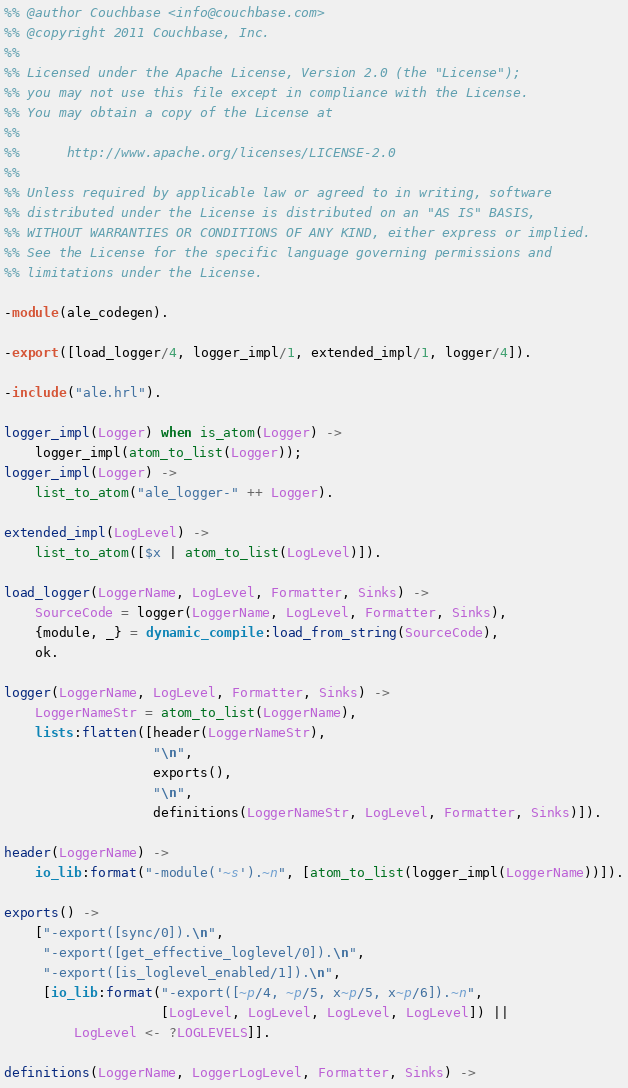<code> <loc_0><loc_0><loc_500><loc_500><_Erlang_>%% @author Couchbase <info@couchbase.com>
%% @copyright 2011 Couchbase, Inc.
%%
%% Licensed under the Apache License, Version 2.0 (the "License");
%% you may not use this file except in compliance with the License.
%% You may obtain a copy of the License at
%%
%%      http://www.apache.org/licenses/LICENSE-2.0
%%
%% Unless required by applicable law or agreed to in writing, software
%% distributed under the License is distributed on an "AS IS" BASIS,
%% WITHOUT WARRANTIES OR CONDITIONS OF ANY KIND, either express or implied.
%% See the License for the specific language governing permissions and
%% limitations under the License.

-module(ale_codegen).

-export([load_logger/4, logger_impl/1, extended_impl/1, logger/4]).

-include("ale.hrl").

logger_impl(Logger) when is_atom(Logger) ->
    logger_impl(atom_to_list(Logger));
logger_impl(Logger) ->
    list_to_atom("ale_logger-" ++ Logger).

extended_impl(LogLevel) ->
    list_to_atom([$x | atom_to_list(LogLevel)]).

load_logger(LoggerName, LogLevel, Formatter, Sinks) ->
    SourceCode = logger(LoggerName, LogLevel, Formatter, Sinks),
    {module, _} = dynamic_compile:load_from_string(SourceCode),
    ok.

logger(LoggerName, LogLevel, Formatter, Sinks) ->
    LoggerNameStr = atom_to_list(LoggerName),
    lists:flatten([header(LoggerNameStr),
                   "\n",
                   exports(),
                   "\n",
                   definitions(LoggerNameStr, LogLevel, Formatter, Sinks)]).

header(LoggerName) ->
    io_lib:format("-module('~s').~n", [atom_to_list(logger_impl(LoggerName))]).

exports() ->
    ["-export([sync/0]).\n",
     "-export([get_effective_loglevel/0]).\n",
     "-export([is_loglevel_enabled/1]).\n",
     [io_lib:format("-export([~p/4, ~p/5, x~p/5, x~p/6]).~n",
                    [LogLevel, LogLevel, LogLevel, LogLevel]) ||
         LogLevel <- ?LOGLEVELS]].

definitions(LoggerName, LoggerLogLevel, Formatter, Sinks) -></code> 